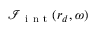<formula> <loc_0><loc_0><loc_500><loc_500>\mathcal { I } _ { i n t } ( r _ { d } , \omega )</formula> 